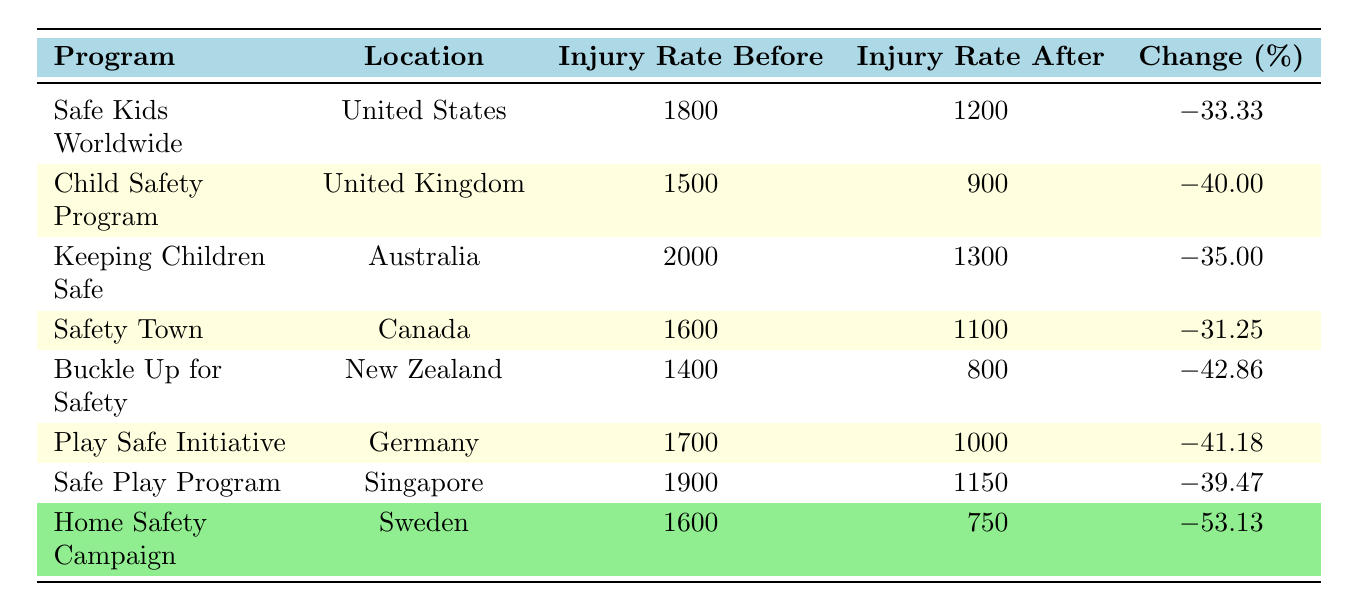What was the injury rate after the Safe Kids Worldwide program? According to the table, the injury rate after the Safe Kids Worldwide program was 1200.
Answer: 1200 Which program had the highest injury rate before the safety education was implemented? Looking at the "Injury Rate Before" column, the Keeping Children Safe program had the highest rate of 2000.
Answer: 2000 What is the percentage change in injury rates for the Home Safety Campaign? The table indicates that the percentage change for the Home Safety Campaign is -53.13%.
Answer: -53.13% How many programs had a percentage change greater than -40%? Checking the percentage changes, the "Safe Kids Worldwide," "Keeping Children Safe," and "Safety Town" programs all had changes less than -40%. Therefore, there are three programs.
Answer: 3 What is the difference in injury rates before and after the Buckle Up for Safety program? For the Buckle Up for Safety program, the difference is calculated as 1400 (before) - 800 (after) = 600.
Answer: 600 Which location had the lowest injury rate after implementing their safety program? Looking at the "Injury Rate After" column, the Home Safety Campaign in Sweden had the lowest rate of 750.
Answer: 750 Is the percentage change for Child Safety Program less than -30%? The percentage change for the Child Safety Program is -40.00%, which is indeed less than -30%.
Answer: Yes What was the average injury rate before implementing the programs across all listed programs? To find the average of the "Injury Rate Before" column: (1800 + 1500 + 2000 + 1600 + 1400 + 1700 + 1900 + 1600) / 8 = 1,675.
Answer: 1675 Which two programs had a percentage change closest to each other? Comparing percentage changes, the "Keeping Children Safe" and "Safe Play Program" programs both had changes of -35.00% and -39.47%, respectively, which are closest to each other.
Answer: Keeping Children Safe and Safe Play Program What was the overall decrease in injury rates from the program with the highest injury rate before implementation to the program with the lowest injury rate after implementation? The program with the highest injury rate before implementation is Keeping Children Safe (2000), and the program with the lowest after is Home Safety Campaign (750). The overall decrease is 2000 - 750 = 1250.
Answer: 1250 